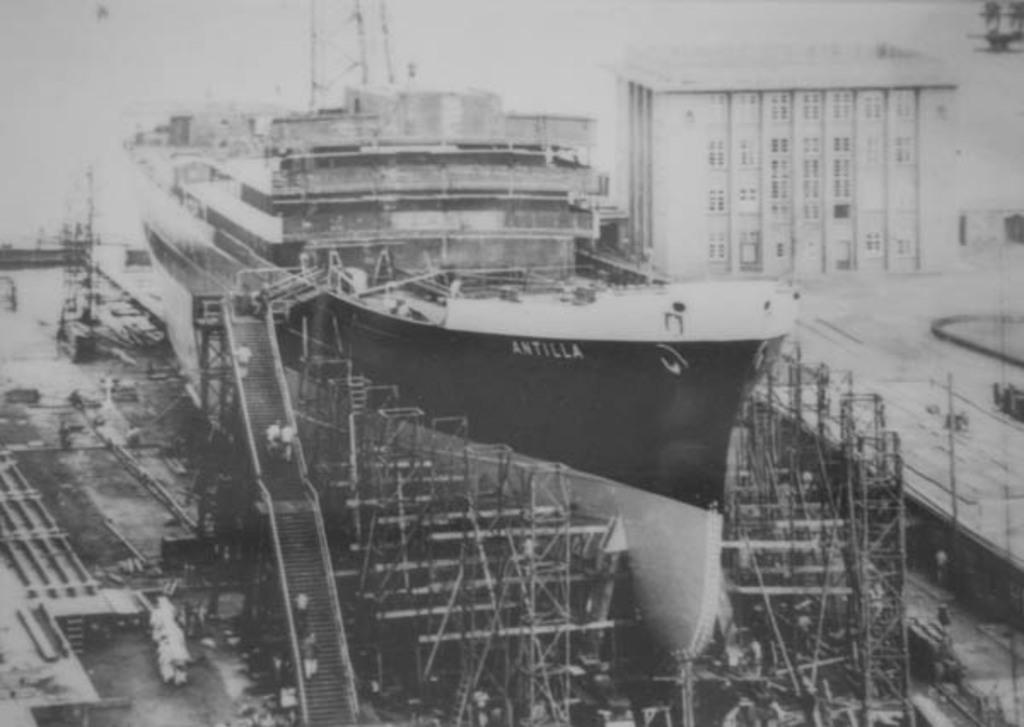<image>
Render a clear and concise summary of the photo. A ship is marked with the word Antilla on the side. 